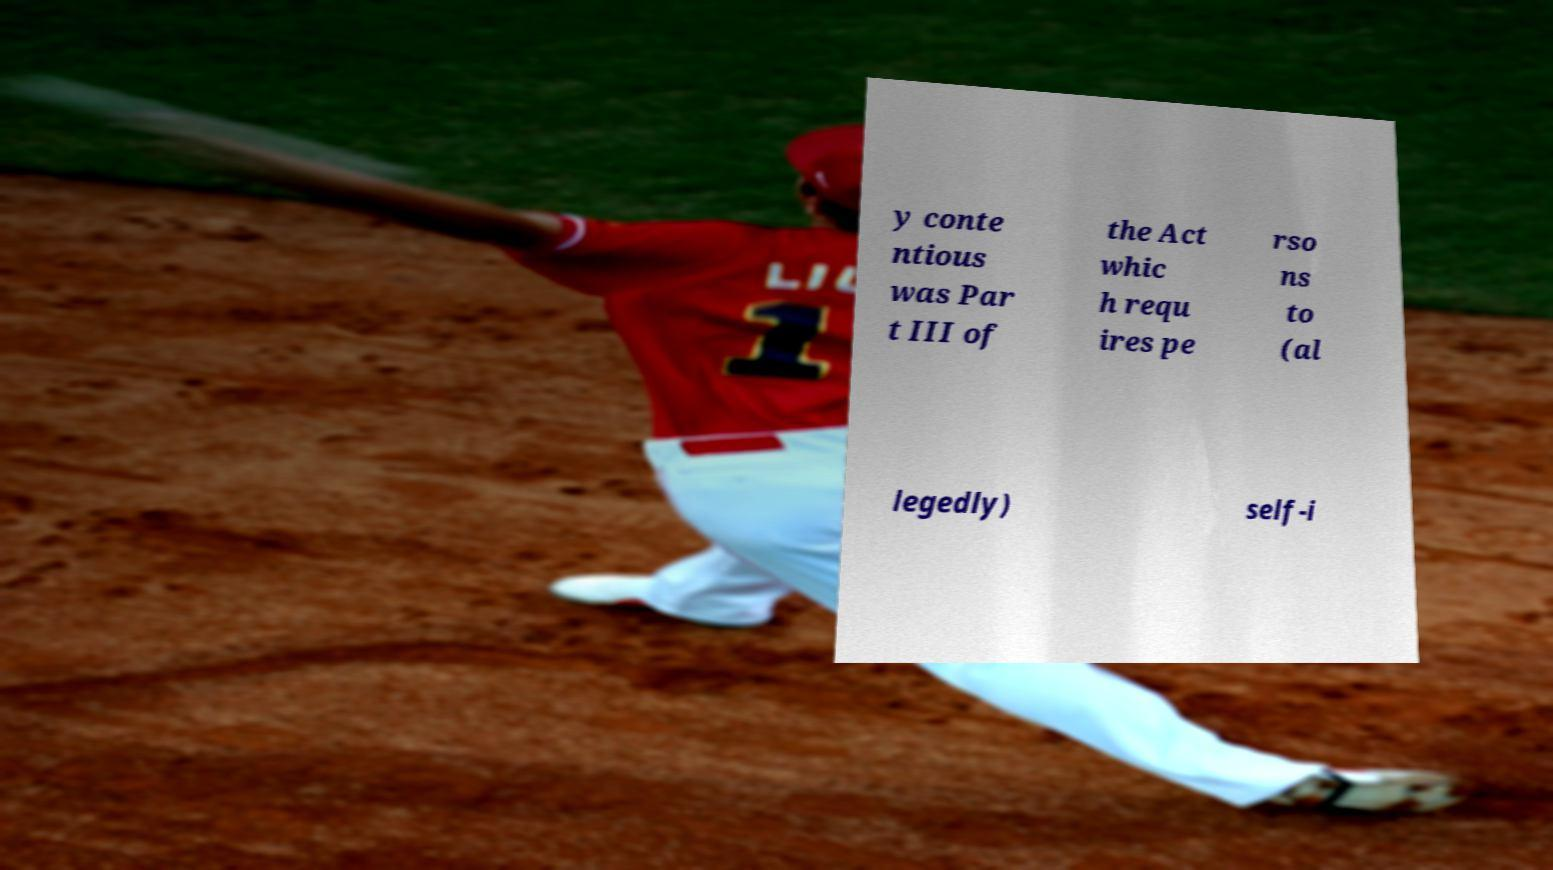Please identify and transcribe the text found in this image. y conte ntious was Par t III of the Act whic h requ ires pe rso ns to (al legedly) self-i 